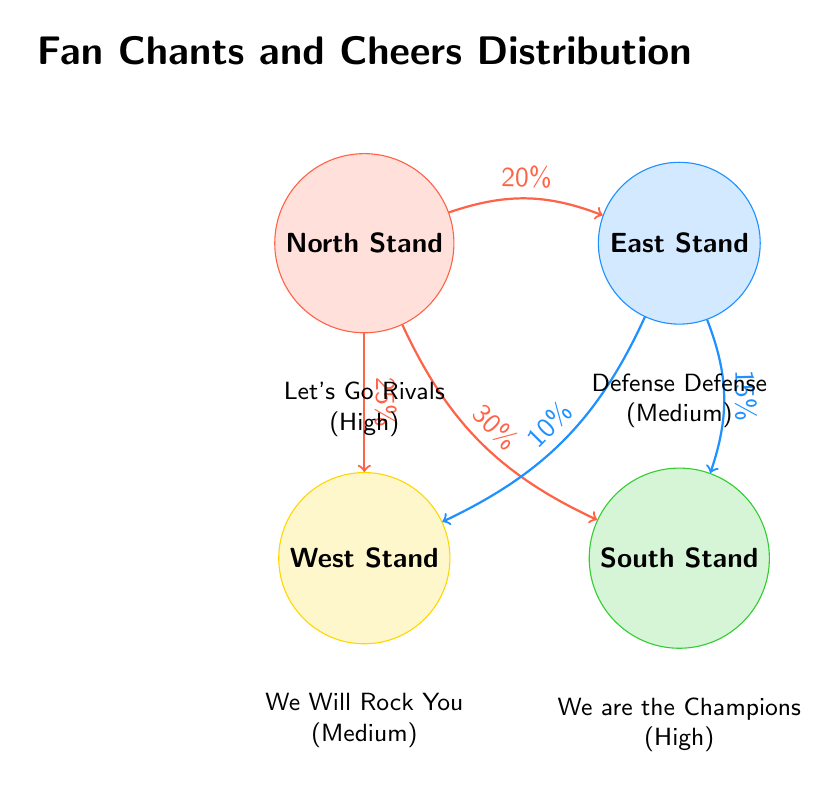What chant is associated with the North Stand? The North Stand is associated with the chant "Let's Go Rivals," which is noted beneath the node in the diagram.
Answer: Let's Go Rivals What is the intensity level of the chant from the South Stand? The diagram indicates that the chant from the South Stand, "We are the Champions," has a high intensity level, as specified below the South Stand node.
Answer: High Which section has the lowest percentage of cheers going to the West Stand? The East Stand has a 10% cheer distribution directed towards the West Stand, which is the lowest percentage mentioned in the cheer distribution lines.
Answer: 10% What percentage of cheers flows from the North Stand to the South Stand? There is a 30% cheer distribution from the North Stand to the South Stand, as shown in the directed line in the diagram.
Answer: 30% Which sections share a chant intensity of medium? The East Stand and the West Stand both have chants with a medium intensity level, as indicated in the respective nodes beneath each stand.
Answer: East Stand, West Stand Total how many cheers are directed from the North Stand? The North Stand has cheers directed towards the East Stand (20%), South Stand (30%), and West Stand (25%), which totals 75% in the directed edges from the North Stand.
Answer: 75% Which stand sends cheers to both the South Stand and the West Stand? The East Stand sends cheers to both the South Stand and the West Stand, as indicated by the outgoing lines from the East Stand node in the diagram.
Answer: East Stand What is the highest intensity chant among the stands? The South Stand has the highest intensity chant, "We are the Champions," as marked below its node in the diagram.
Answer: We are the Champions How many stands are represented in the diagram? Four stands are represented: North Stand, East Stand, South Stand, and West Stand, as listed in the sections of the diagram.
Answer: 4 